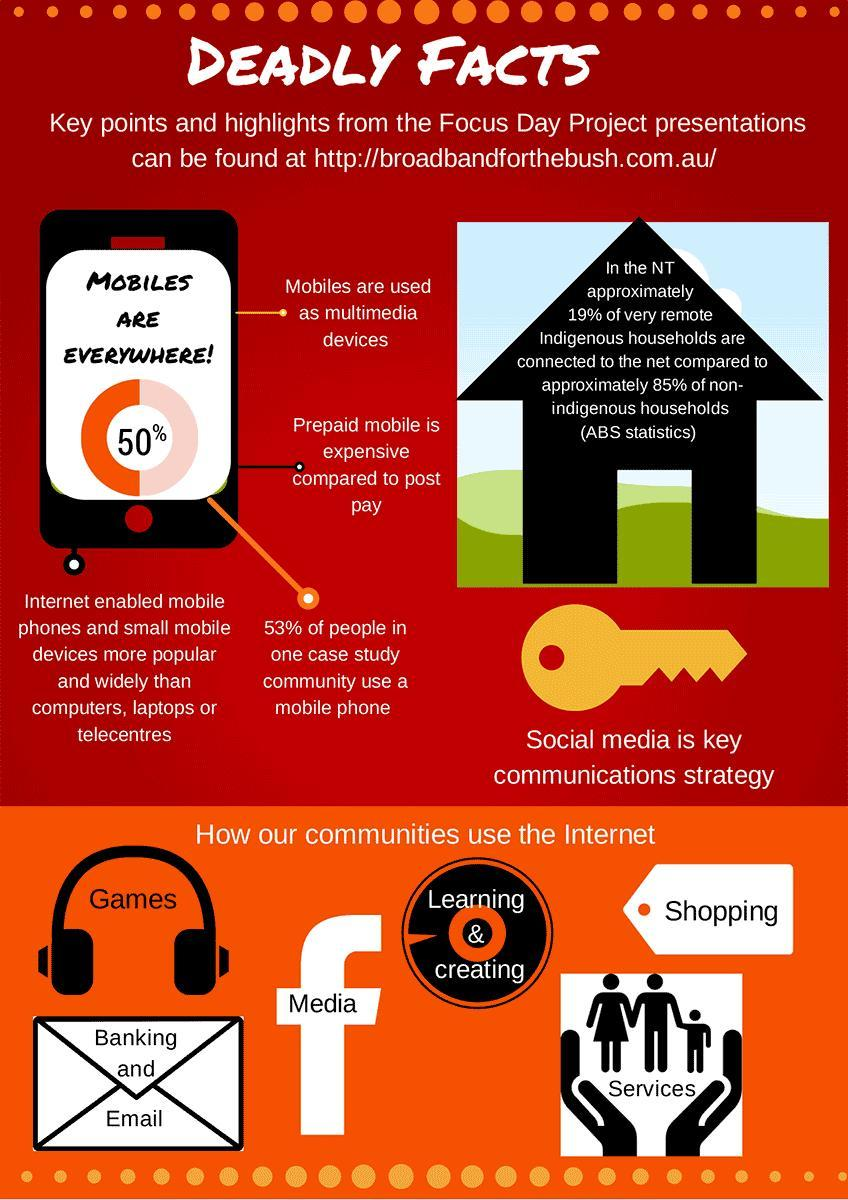In which color Facebook logo is shown- black, white, red, blue?
Answer the question with a short phrase. white What is the text written inside the Facebook logo? Media What is the major reason for the wide usage of mobile phones? Internet How many different types of usage of Internet is depicted in the info graphic? 6 